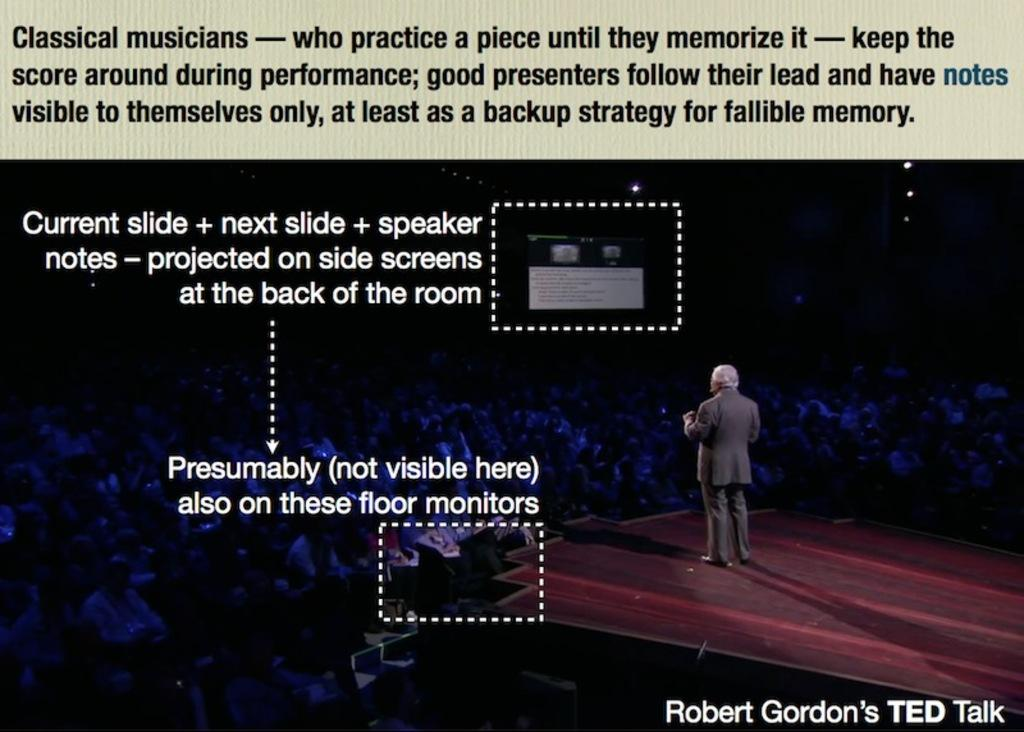What can be seen in the image? There is a poster in the image, with multiple persons sitting on it. What else is present in the image? There is a man wearing a suit on a dais, and he is talking. Is there any text visible in the image? Yes, there is text to the left of the image. Can you see a volleyball being played in the image? No, there is no volleyball or any indication of a game being played in the image. What does the man's dad think about his speech? There is no information about the man's dad in the image, so we cannot determine his opinion on the speech. 